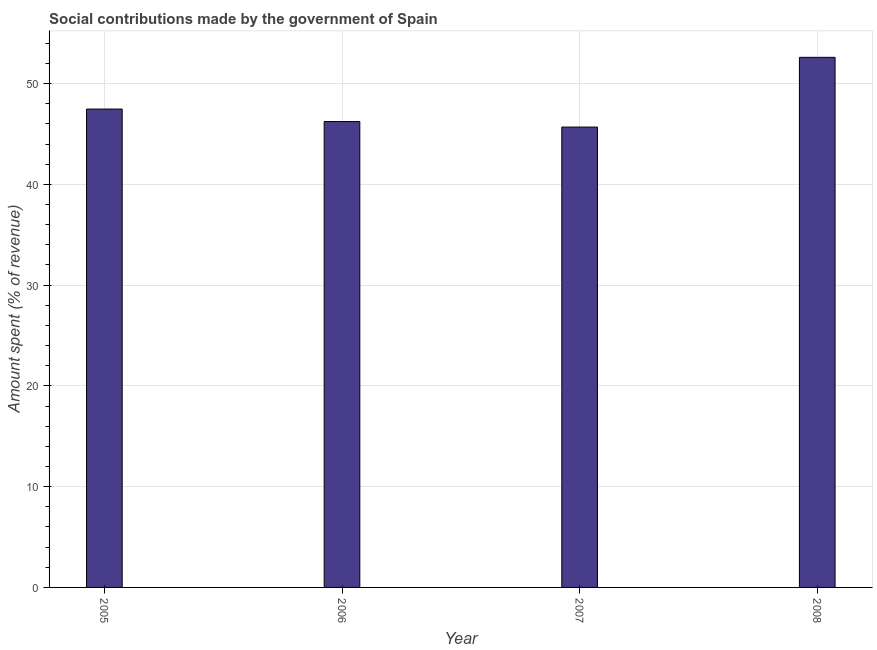Does the graph contain any zero values?
Your answer should be very brief. No. What is the title of the graph?
Offer a very short reply. Social contributions made by the government of Spain. What is the label or title of the Y-axis?
Your answer should be compact. Amount spent (% of revenue). What is the amount spent in making social contributions in 2007?
Give a very brief answer. 45.69. Across all years, what is the maximum amount spent in making social contributions?
Offer a very short reply. 52.61. Across all years, what is the minimum amount spent in making social contributions?
Provide a short and direct response. 45.69. In which year was the amount spent in making social contributions minimum?
Provide a succinct answer. 2007. What is the sum of the amount spent in making social contributions?
Your answer should be very brief. 192. What is the difference between the amount spent in making social contributions in 2006 and 2007?
Keep it short and to the point. 0.55. What is the average amount spent in making social contributions per year?
Give a very brief answer. 48. What is the median amount spent in making social contributions?
Provide a succinct answer. 46.85. In how many years, is the amount spent in making social contributions greater than 46 %?
Give a very brief answer. 3. Do a majority of the years between 2008 and 2007 (inclusive) have amount spent in making social contributions greater than 36 %?
Your answer should be compact. No. Is the amount spent in making social contributions in 2006 less than that in 2008?
Provide a succinct answer. Yes. Is the difference between the amount spent in making social contributions in 2006 and 2007 greater than the difference between any two years?
Provide a short and direct response. No. What is the difference between the highest and the second highest amount spent in making social contributions?
Give a very brief answer. 5.13. What is the difference between the highest and the lowest amount spent in making social contributions?
Provide a succinct answer. 6.92. In how many years, is the amount spent in making social contributions greater than the average amount spent in making social contributions taken over all years?
Provide a short and direct response. 1. Are all the bars in the graph horizontal?
Your answer should be very brief. No. Are the values on the major ticks of Y-axis written in scientific E-notation?
Your answer should be very brief. No. What is the Amount spent (% of revenue) of 2005?
Your response must be concise. 47.48. What is the Amount spent (% of revenue) in 2006?
Offer a terse response. 46.23. What is the Amount spent (% of revenue) of 2007?
Your response must be concise. 45.69. What is the Amount spent (% of revenue) in 2008?
Offer a terse response. 52.61. What is the difference between the Amount spent (% of revenue) in 2005 and 2006?
Offer a very short reply. 1.24. What is the difference between the Amount spent (% of revenue) in 2005 and 2007?
Your response must be concise. 1.79. What is the difference between the Amount spent (% of revenue) in 2005 and 2008?
Your response must be concise. -5.13. What is the difference between the Amount spent (% of revenue) in 2006 and 2007?
Give a very brief answer. 0.55. What is the difference between the Amount spent (% of revenue) in 2006 and 2008?
Ensure brevity in your answer.  -6.37. What is the difference between the Amount spent (% of revenue) in 2007 and 2008?
Your response must be concise. -6.92. What is the ratio of the Amount spent (% of revenue) in 2005 to that in 2006?
Your response must be concise. 1.03. What is the ratio of the Amount spent (% of revenue) in 2005 to that in 2007?
Offer a very short reply. 1.04. What is the ratio of the Amount spent (% of revenue) in 2005 to that in 2008?
Offer a very short reply. 0.9. What is the ratio of the Amount spent (% of revenue) in 2006 to that in 2008?
Offer a terse response. 0.88. What is the ratio of the Amount spent (% of revenue) in 2007 to that in 2008?
Offer a terse response. 0.87. 